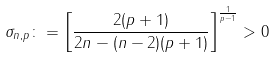<formula> <loc_0><loc_0><loc_500><loc_500>\sigma _ { n , p } \colon = \left [ \frac { 2 ( p + 1 ) } { 2 n - ( n - 2 ) ( p + 1 ) } \right ] ^ { \frac { 1 } { p - 1 } } > 0</formula> 